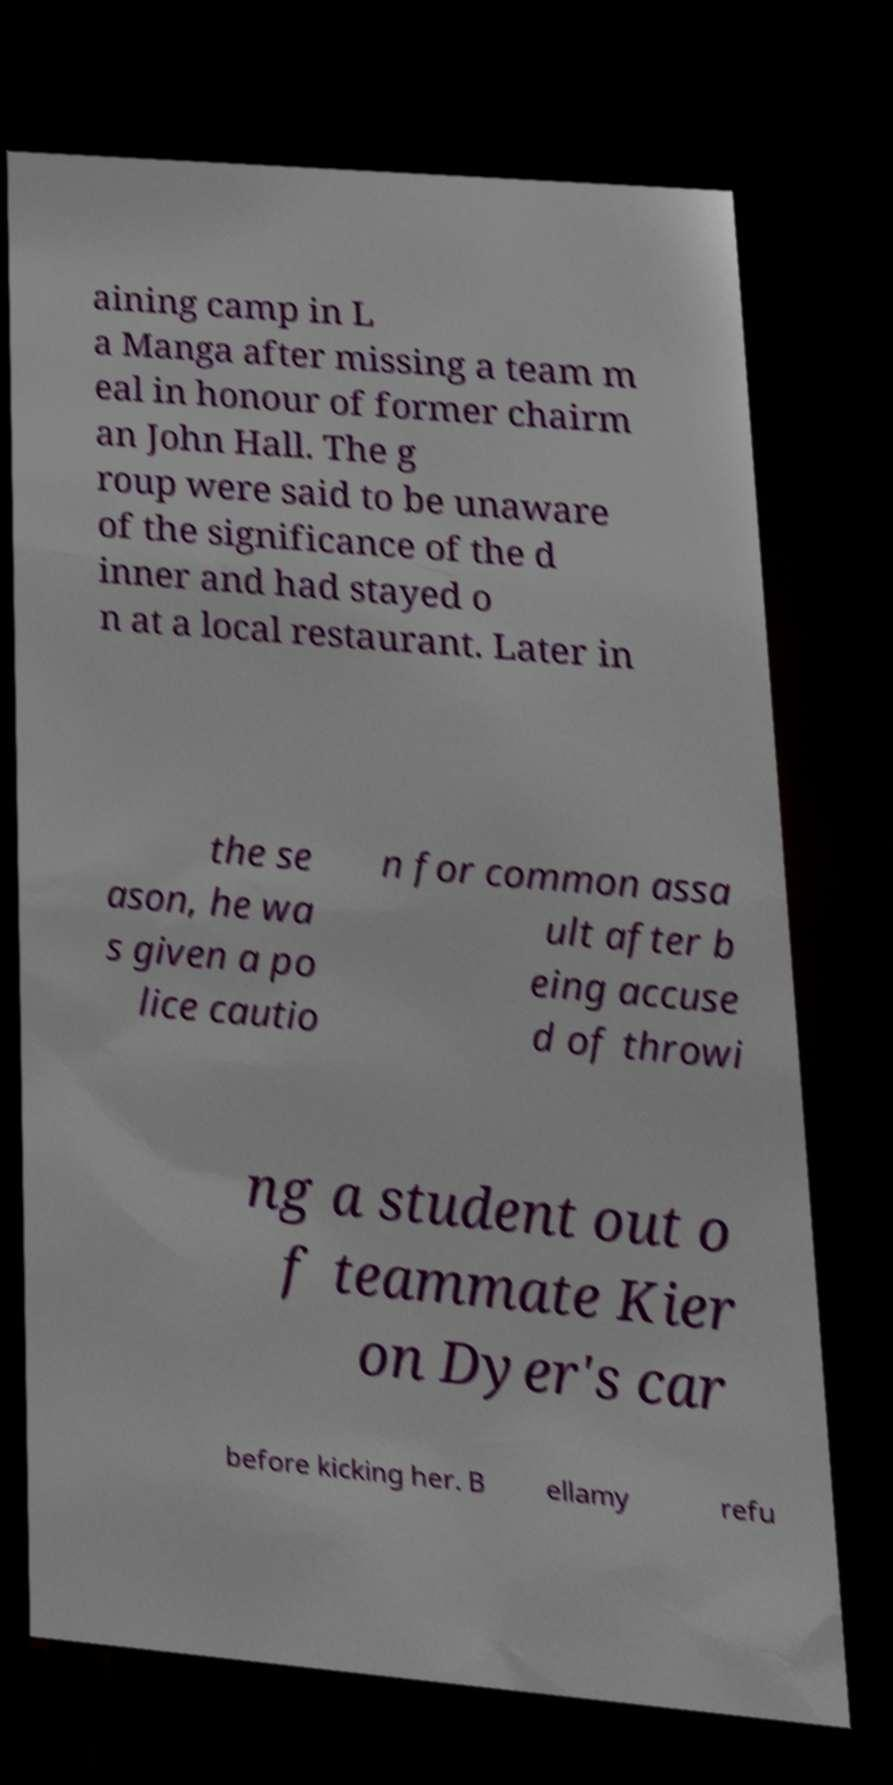What messages or text are displayed in this image? I need them in a readable, typed format. aining camp in L a Manga after missing a team m eal in honour of former chairm an John Hall. The g roup were said to be unaware of the significance of the d inner and had stayed o n at a local restaurant. Later in the se ason, he wa s given a po lice cautio n for common assa ult after b eing accuse d of throwi ng a student out o f teammate Kier on Dyer's car before kicking her. B ellamy refu 